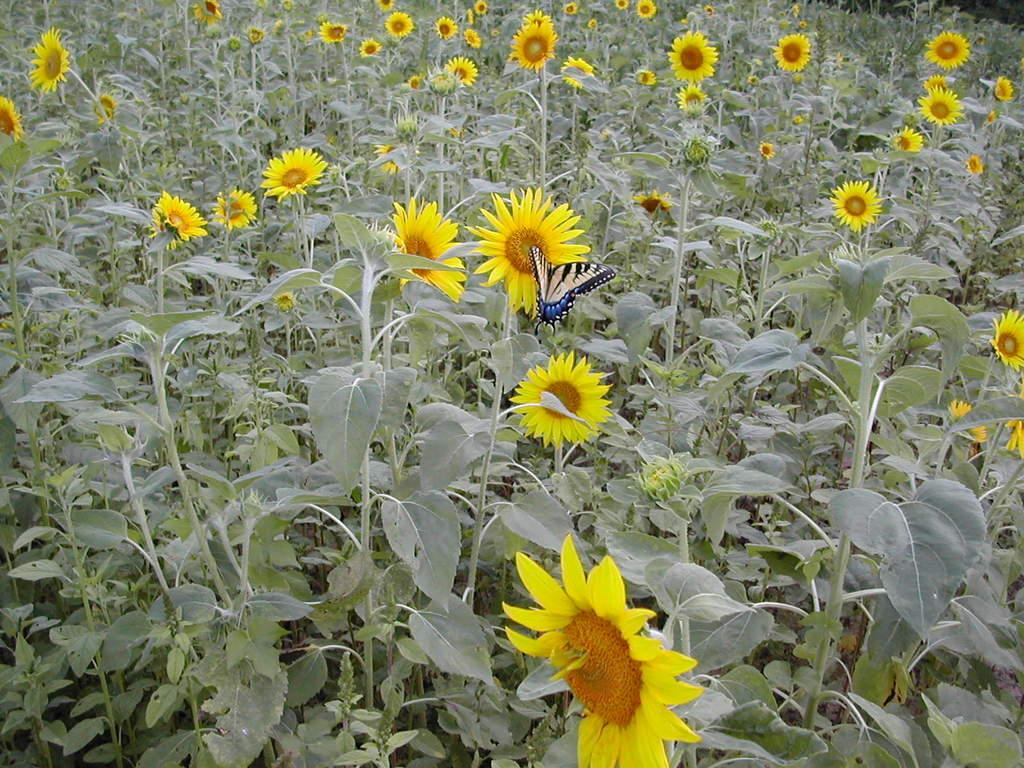What type of insect is present in the picture? There is a butterfly in the picture. What type of plants can be seen in the picture? There are sunflower plants in the picture. What grade does the butterfly receive for its performance in the picture? There is no grading system or performance evaluation for the butterfly in the picture. 